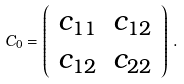<formula> <loc_0><loc_0><loc_500><loc_500>C _ { 0 } = \left ( \begin{array} { c c } c _ { 1 1 } & c _ { 1 2 } \\ c _ { 1 2 } & c _ { 2 2 } \end{array} \right ) \, .</formula> 